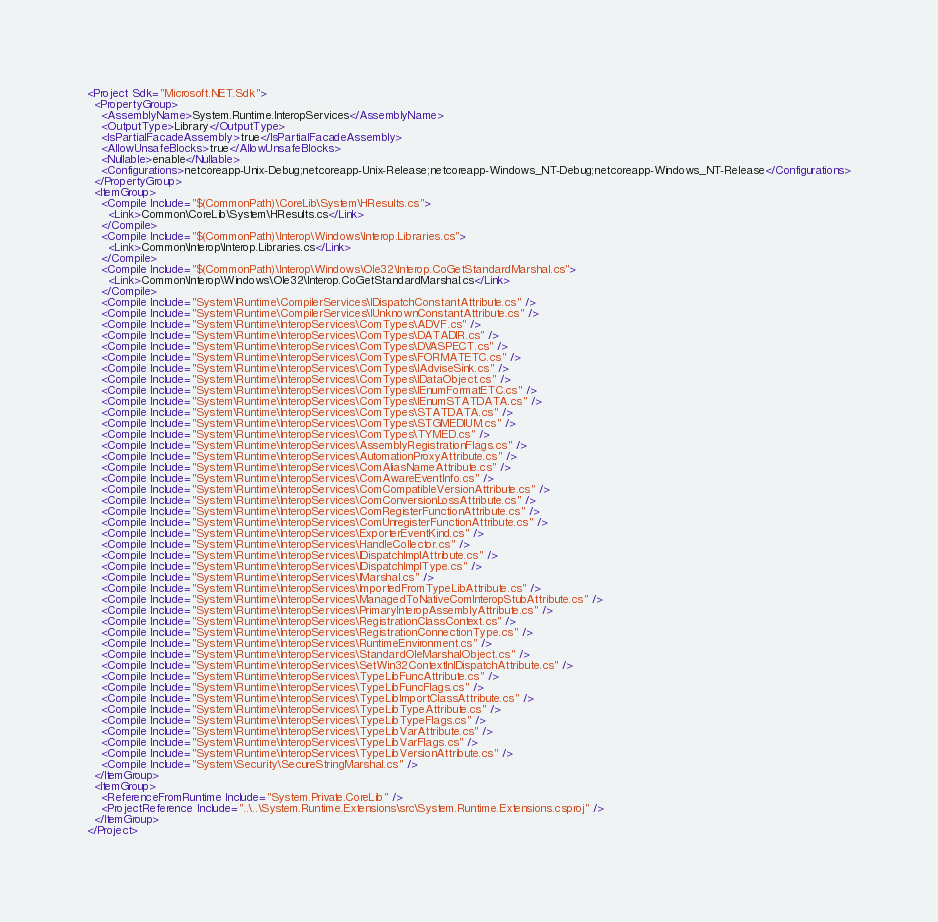<code> <loc_0><loc_0><loc_500><loc_500><_XML_><Project Sdk="Microsoft.NET.Sdk">
  <PropertyGroup>
    <AssemblyName>System.Runtime.InteropServices</AssemblyName>
    <OutputType>Library</OutputType>
    <IsPartialFacadeAssembly>true</IsPartialFacadeAssembly>
    <AllowUnsafeBlocks>true</AllowUnsafeBlocks>
    <Nullable>enable</Nullable>
    <Configurations>netcoreapp-Unix-Debug;netcoreapp-Unix-Release;netcoreapp-Windows_NT-Debug;netcoreapp-Windows_NT-Release</Configurations>
  </PropertyGroup>
  <ItemGroup>
    <Compile Include="$(CommonPath)\CoreLib\System\HResults.cs">
      <Link>Common\CoreLib\System\HResults.cs</Link>
    </Compile>
    <Compile Include="$(CommonPath)\Interop\Windows\Interop.Libraries.cs">
      <Link>Common\Interop\Interop.Libraries.cs</Link>
    </Compile>
    <Compile Include="$(CommonPath)\Interop\Windows\Ole32\Interop.CoGetStandardMarshal.cs">
      <Link>Common\Interop\Windows\Ole32\Interop.CoGetStandardMarshal.cs</Link>
    </Compile>
    <Compile Include="System\Runtime\CompilerServices\IDispatchConstantAttribute.cs" />
    <Compile Include="System\Runtime\CompilerServices\IUnknownConstantAttribute.cs" />
    <Compile Include="System\Runtime\InteropServices\ComTypes\ADVF.cs" />
    <Compile Include="System\Runtime\InteropServices\ComTypes\DATADIR.cs" />
    <Compile Include="System\Runtime\InteropServices\ComTypes\DVASPECT.cs" />
    <Compile Include="System\Runtime\InteropServices\ComTypes\FORMATETC.cs" />
    <Compile Include="System\Runtime\InteropServices\ComTypes\IAdviseSink.cs" />
    <Compile Include="System\Runtime\InteropServices\ComTypes\IDataObject.cs" />
    <Compile Include="System\Runtime\InteropServices\ComTypes\IEnumFormatETC.cs" />
    <Compile Include="System\Runtime\InteropServices\ComTypes\IEnumSTATDATA.cs" />
    <Compile Include="System\Runtime\InteropServices\ComTypes\STATDATA.cs" />
    <Compile Include="System\Runtime\InteropServices\ComTypes\STGMEDIUM.cs" />
    <Compile Include="System\Runtime\InteropServices\ComTypes\TYMED.cs" />
    <Compile Include="System\Runtime\InteropServices\AssemblyRegistrationFlags.cs" />
    <Compile Include="System\Runtime\InteropServices\AutomationProxyAttribute.cs" />
    <Compile Include="System\Runtime\InteropServices\ComAliasNameAttribute.cs" />
    <Compile Include="System\Runtime\InteropServices\ComAwareEventInfo.cs" />
    <Compile Include="System\Runtime\InteropServices\ComCompatibleVersionAttribute.cs" />
    <Compile Include="System\Runtime\InteropServices\ComConversionLossAttribute.cs" />
    <Compile Include="System\Runtime\InteropServices\ComRegisterFunctionAttribute.cs" />
    <Compile Include="System\Runtime\InteropServices\ComUnregisterFunctionAttribute.cs" />
    <Compile Include="System\Runtime\InteropServices\ExporterEventKind.cs" />
    <Compile Include="System\Runtime\InteropServices\HandleCollector.cs" />
    <Compile Include="System\Runtime\InteropServices\IDispatchImplAttribute.cs" />
    <Compile Include="System\Runtime\InteropServices\IDispatchImplType.cs" />
    <Compile Include="System\Runtime\InteropServices\IMarshal.cs" />
    <Compile Include="System\Runtime\InteropServices\ImportedFromTypeLibAttribute.cs" />
    <Compile Include="System\Runtime\InteropServices\ManagedToNativeComInteropStubAttribute.cs" />
    <Compile Include="System\Runtime\InteropServices\PrimaryInteropAssemblyAttribute.cs" />
    <Compile Include="System\Runtime\InteropServices\RegistrationClassContext.cs" />
    <Compile Include="System\Runtime\InteropServices\RegistrationConnectionType.cs" />
    <Compile Include="System\Runtime\InteropServices\RuntimeEnvironment.cs" />
    <Compile Include="System\Runtime\InteropServices\StandardOleMarshalObject.cs" />
    <Compile Include="System\Runtime\InteropServices\SetWin32ContextInIDispatchAttribute.cs" />
    <Compile Include="System\Runtime\InteropServices\TypeLibFuncAttribute.cs" />
    <Compile Include="System\Runtime\InteropServices\TypeLibFuncFlags.cs" />
    <Compile Include="System\Runtime\InteropServices\TypeLibImportClassAttribute.cs" />
    <Compile Include="System\Runtime\InteropServices\TypeLibTypeAttribute.cs" />
    <Compile Include="System\Runtime\InteropServices\TypeLibTypeFlags.cs" />
    <Compile Include="System\Runtime\InteropServices\TypeLibVarAttribute.cs" />
    <Compile Include="System\Runtime\InteropServices\TypeLibVarFlags.cs" />
    <Compile Include="System\Runtime\InteropServices\TypeLibVersionAttribute.cs" />
    <Compile Include="System\Security\SecureStringMarshal.cs" />
  </ItemGroup>
  <ItemGroup>
    <ReferenceFromRuntime Include="System.Private.CoreLib" />
    <ProjectReference Include="..\..\System.Runtime.Extensions\src\System.Runtime.Extensions.csproj" />
  </ItemGroup>
</Project>
</code> 